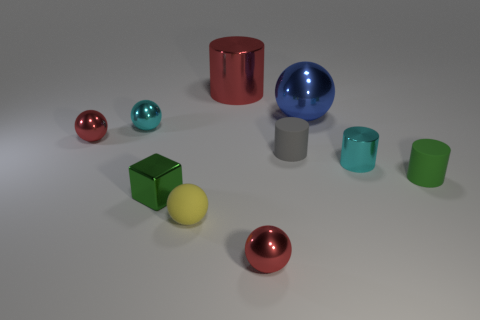Subtract all tiny cyan cylinders. How many cylinders are left? 3 Subtract all red cylinders. How many cylinders are left? 3 Subtract all cylinders. How many objects are left? 6 Subtract all purple blocks. How many green cylinders are left? 1 Subtract 1 blue balls. How many objects are left? 9 Subtract 1 blocks. How many blocks are left? 0 Subtract all yellow blocks. Subtract all yellow cylinders. How many blocks are left? 1 Subtract all large purple cylinders. Subtract all large blue balls. How many objects are left? 9 Add 9 tiny cyan shiny balls. How many tiny cyan shiny balls are left? 10 Add 2 cylinders. How many cylinders exist? 6 